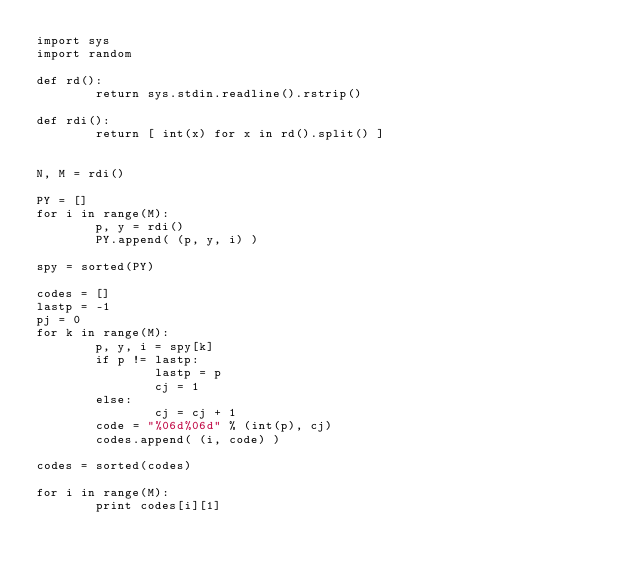<code> <loc_0><loc_0><loc_500><loc_500><_Python_>import sys
import random

def rd():
        return sys.stdin.readline().rstrip()

def rdi():
        return [ int(x) for x in rd().split() ]


N, M = rdi()

PY = []
for i in range(M):
        p, y = rdi()
        PY.append( (p, y, i) )

spy = sorted(PY)

codes = []
lastp = -1
pj = 0
for k in range(M):
        p, y, i = spy[k]
        if p != lastp:
                lastp = p
                cj = 1
        else:
                cj = cj + 1
        code = "%06d%06d" % (int(p), cj)
        codes.append( (i, code) )

codes = sorted(codes)

for i in range(M):
        print codes[i][1]

</code> 